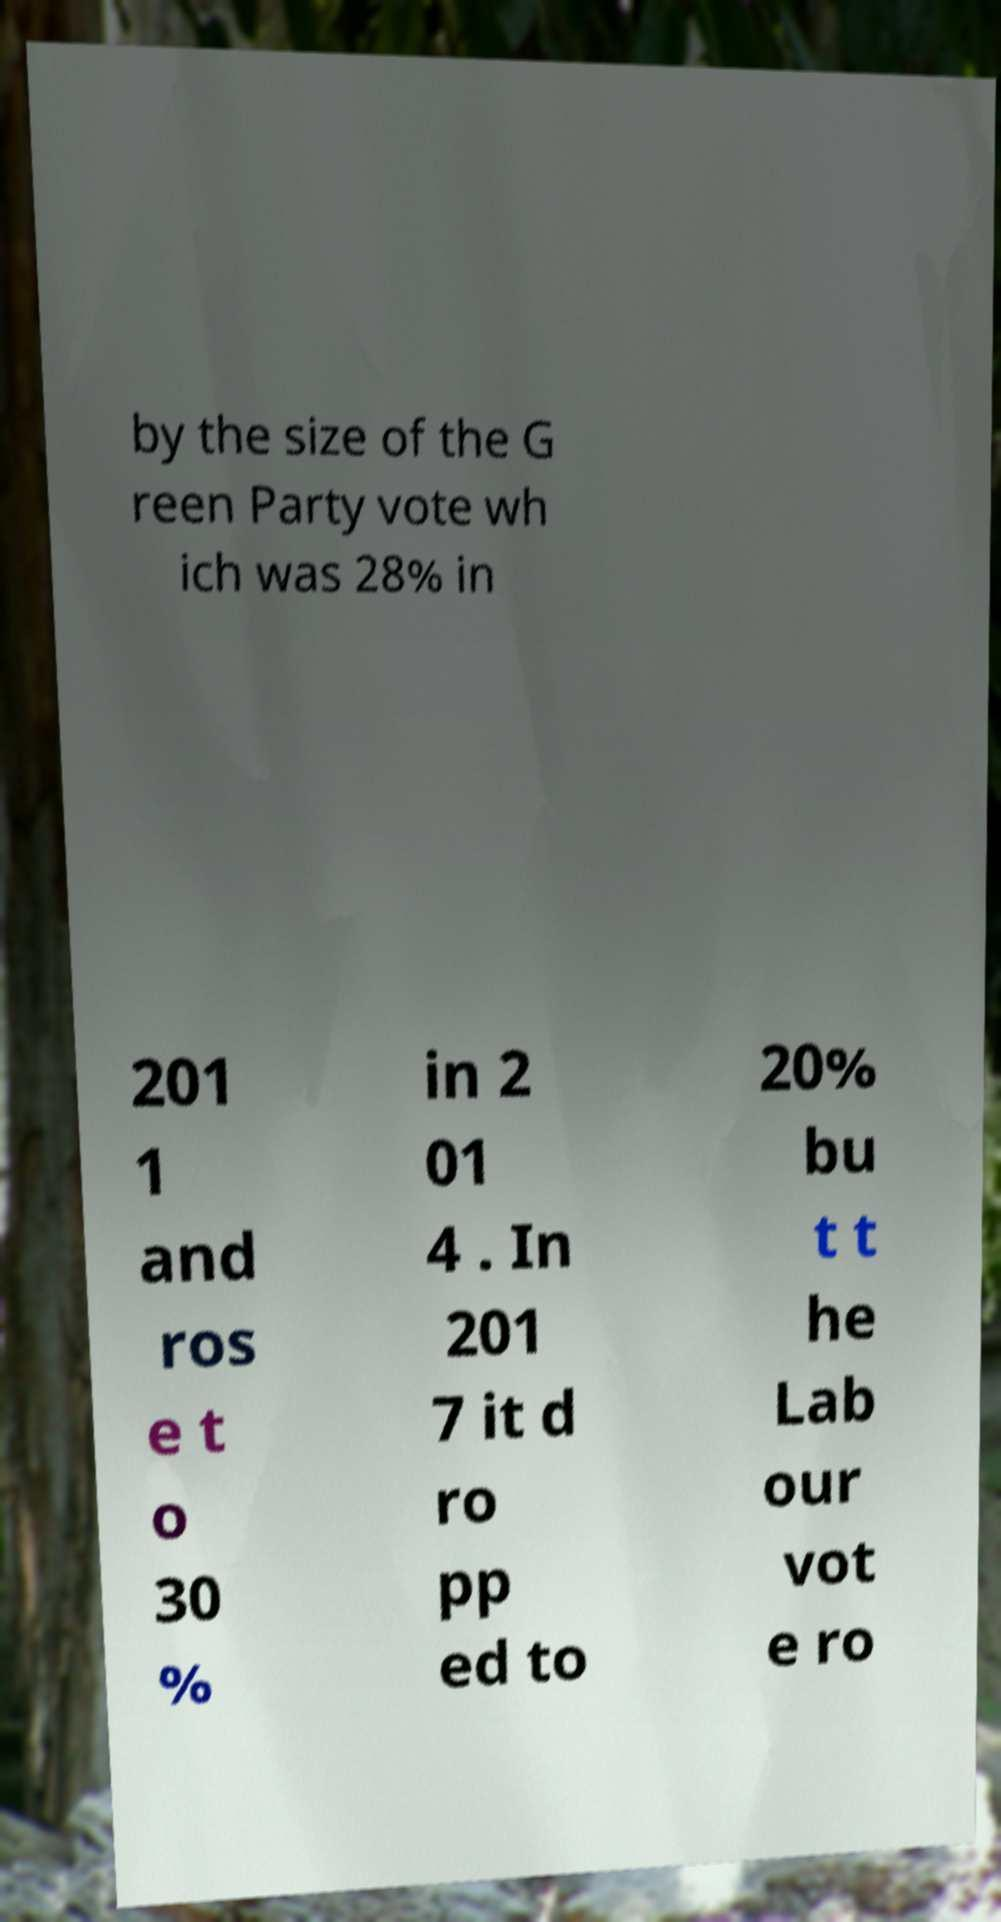For documentation purposes, I need the text within this image transcribed. Could you provide that? by the size of the G reen Party vote wh ich was 28% in 201 1 and ros e t o 30 % in 2 01 4 . In 201 7 it d ro pp ed to 20% bu t t he Lab our vot e ro 